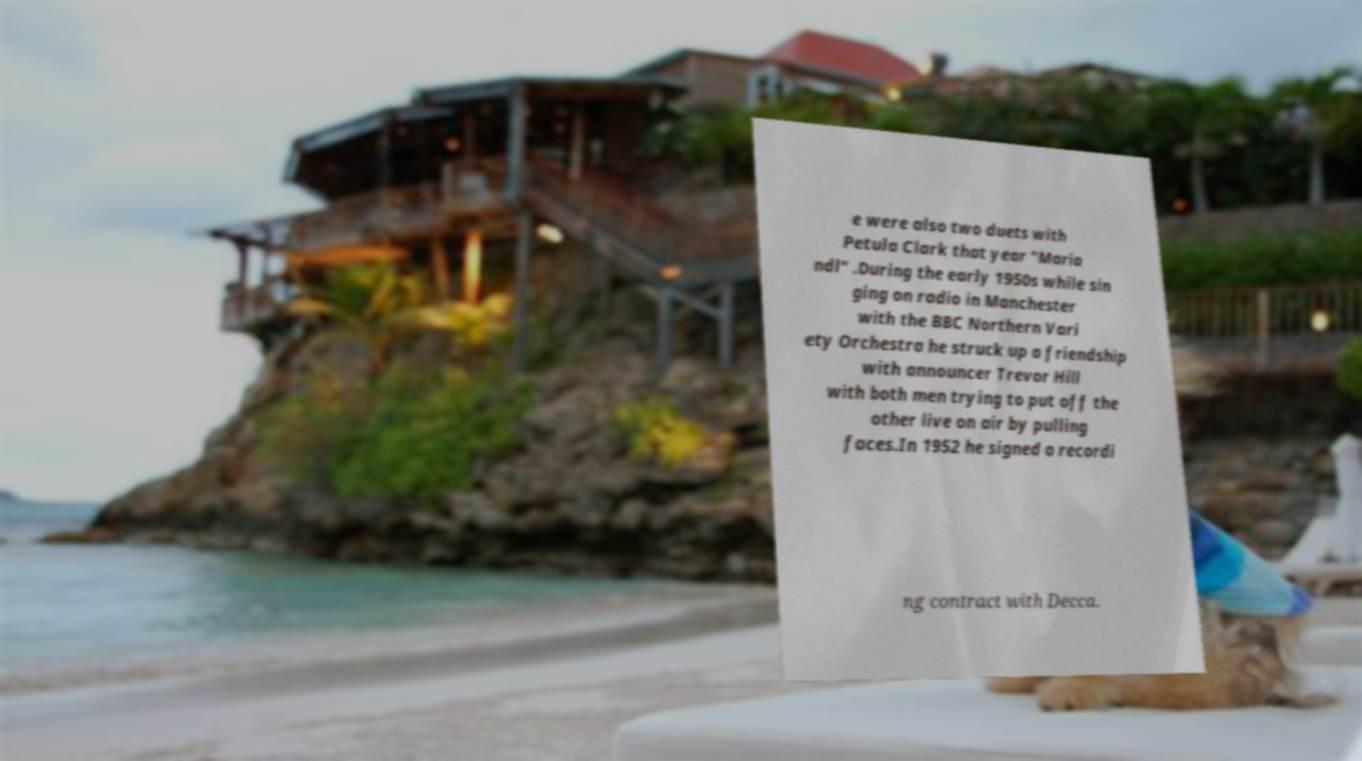What messages or text are displayed in this image? I need them in a readable, typed format. e were also two duets with Petula Clark that year "Maria ndl" .During the early 1950s while sin ging on radio in Manchester with the BBC Northern Vari ety Orchestra he struck up a friendship with announcer Trevor Hill with both men trying to put off the other live on air by pulling faces.In 1952 he signed a recordi ng contract with Decca. 